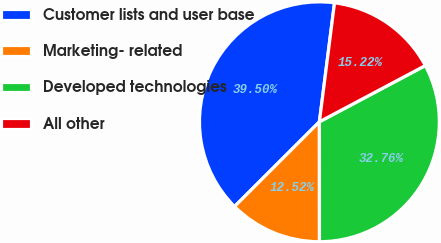Convert chart to OTSL. <chart><loc_0><loc_0><loc_500><loc_500><pie_chart><fcel>Customer lists and user base<fcel>Marketing- related<fcel>Developed technologies<fcel>All other<nl><fcel>39.5%<fcel>12.52%<fcel>32.76%<fcel>15.22%<nl></chart> 